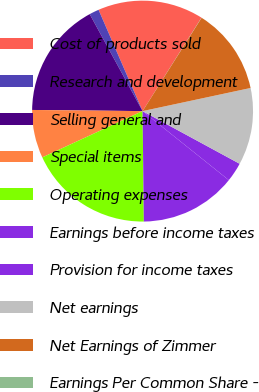Convert chart to OTSL. <chart><loc_0><loc_0><loc_500><loc_500><pie_chart><fcel>Cost of products sold<fcel>Research and development<fcel>Selling general and<fcel>Special items<fcel>Operating expenses<fcel>Earnings before income taxes<fcel>Provision for income taxes<fcel>Net earnings<fcel>Net Earnings of Zimmer<fcel>Earnings Per Common Share -<nl><fcel>15.48%<fcel>1.42%<fcel>16.89%<fcel>7.05%<fcel>18.3%<fcel>14.08%<fcel>2.83%<fcel>11.27%<fcel>12.67%<fcel>0.02%<nl></chart> 